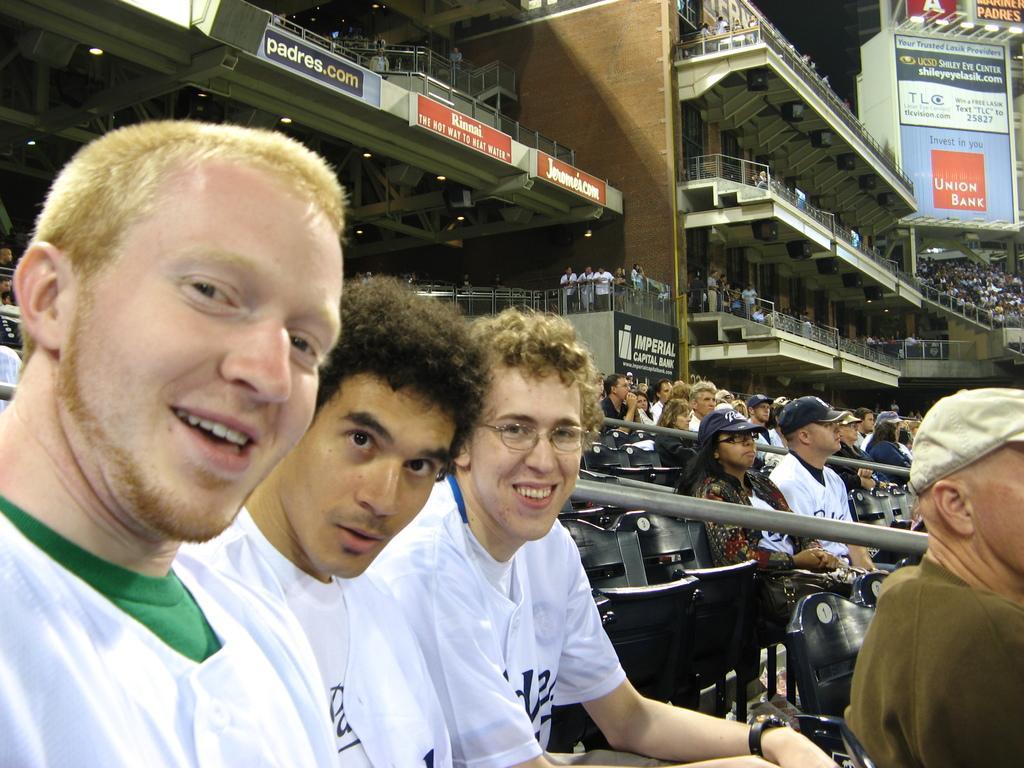How would you summarize this image in a sentence or two? In this image I can see people among them these men are wearing t-shirts. In the background I can see boards, fence, chairs and other objects. 